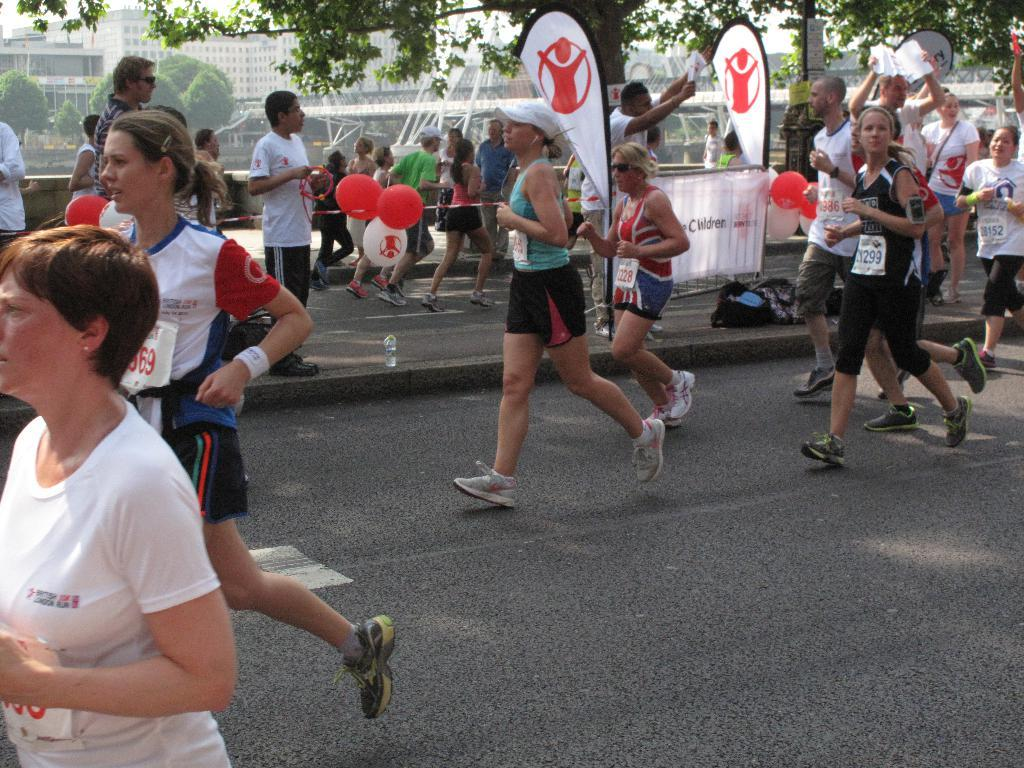What are the people in the image doing? There are people running on the roads in the image. Are there any people not running in the image? Yes, some people are standing in the image. What can be seen in the image besides people? There are flags visible in the image. What is visible in the background of the image? There are buildings and trees in the background of the image. Can you see a giraffe carrying a yoke in the image? No, there is no giraffe or yoke present in the image. 